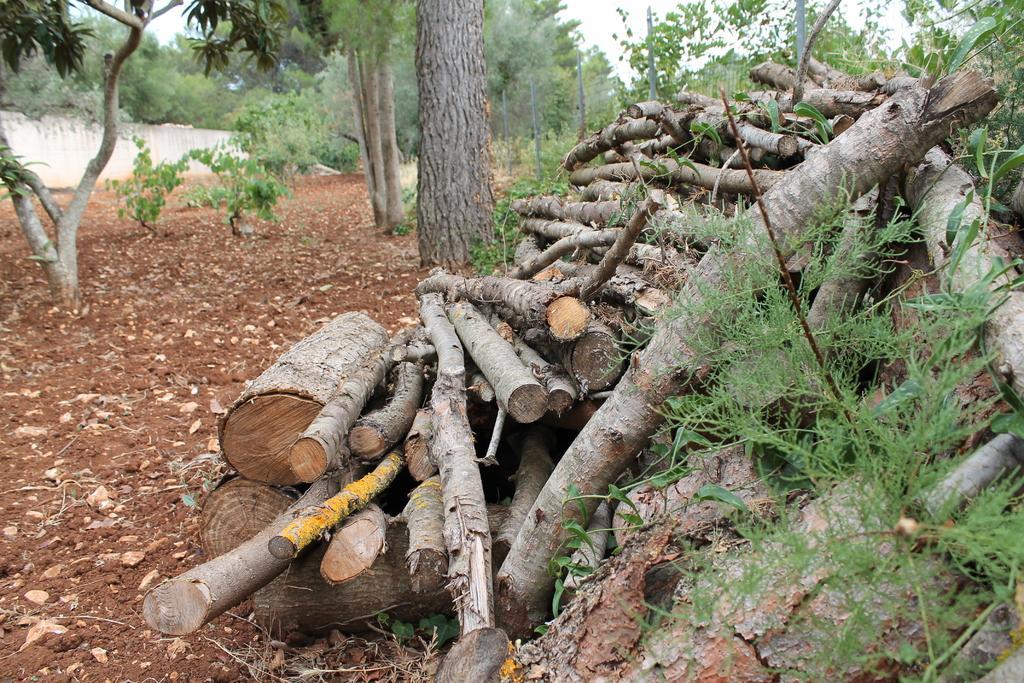Can you describe this image briefly? In the center of the image we can see logs, grass, trees, some plants are present. At the top of the image mesh, sky ,wall are there. On the left side of the image ground is there. 